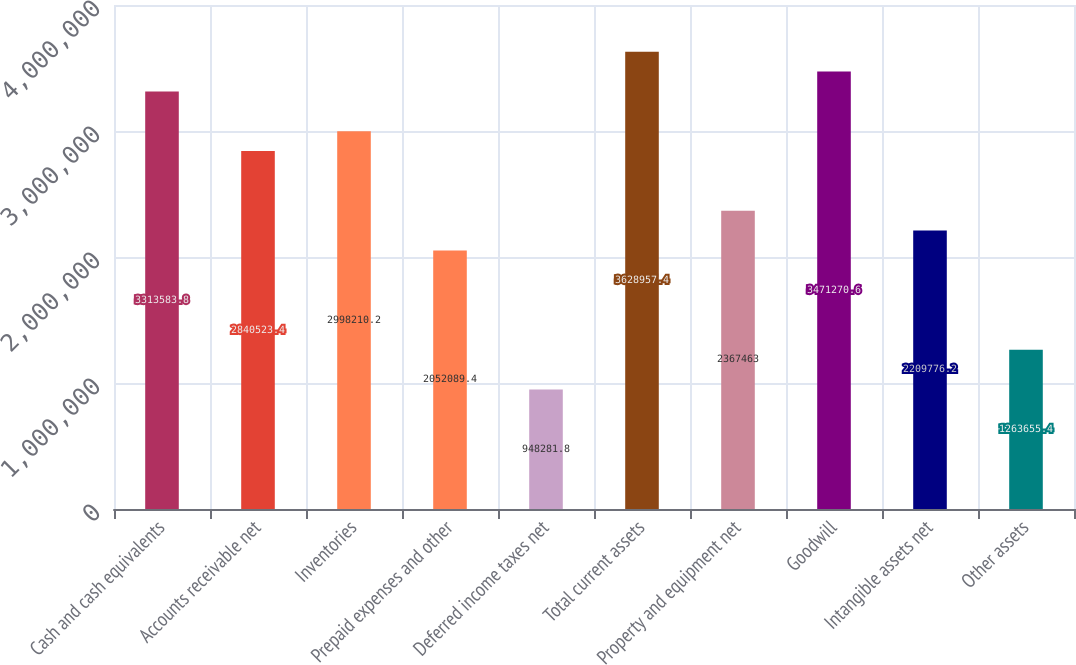Convert chart. <chart><loc_0><loc_0><loc_500><loc_500><bar_chart><fcel>Cash and cash equivalents<fcel>Accounts receivable net<fcel>Inventories<fcel>Prepaid expenses and other<fcel>Deferred income taxes net<fcel>Total current assets<fcel>Property and equipment net<fcel>Goodwill<fcel>Intangible assets net<fcel>Other assets<nl><fcel>3.31358e+06<fcel>2.84052e+06<fcel>2.99821e+06<fcel>2.05209e+06<fcel>948282<fcel>3.62896e+06<fcel>2.36746e+06<fcel>3.47127e+06<fcel>2.20978e+06<fcel>1.26366e+06<nl></chart> 